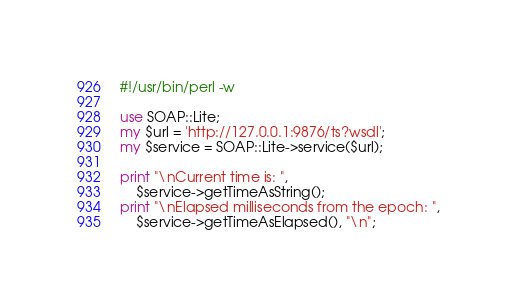<code> <loc_0><loc_0><loc_500><loc_500><_Perl_>#!/usr/bin/perl -w

use SOAP::Lite;
my $url = 'http://127.0.0.1:9876/ts?wsdl';
my $service = SOAP::Lite->service($url);

print "\nCurrent time is: ", 
    $service->getTimeAsString();
print "\nElapsed milliseconds from the epoch: ", 
    $service->getTimeAsElapsed(), "\n";
</code> 